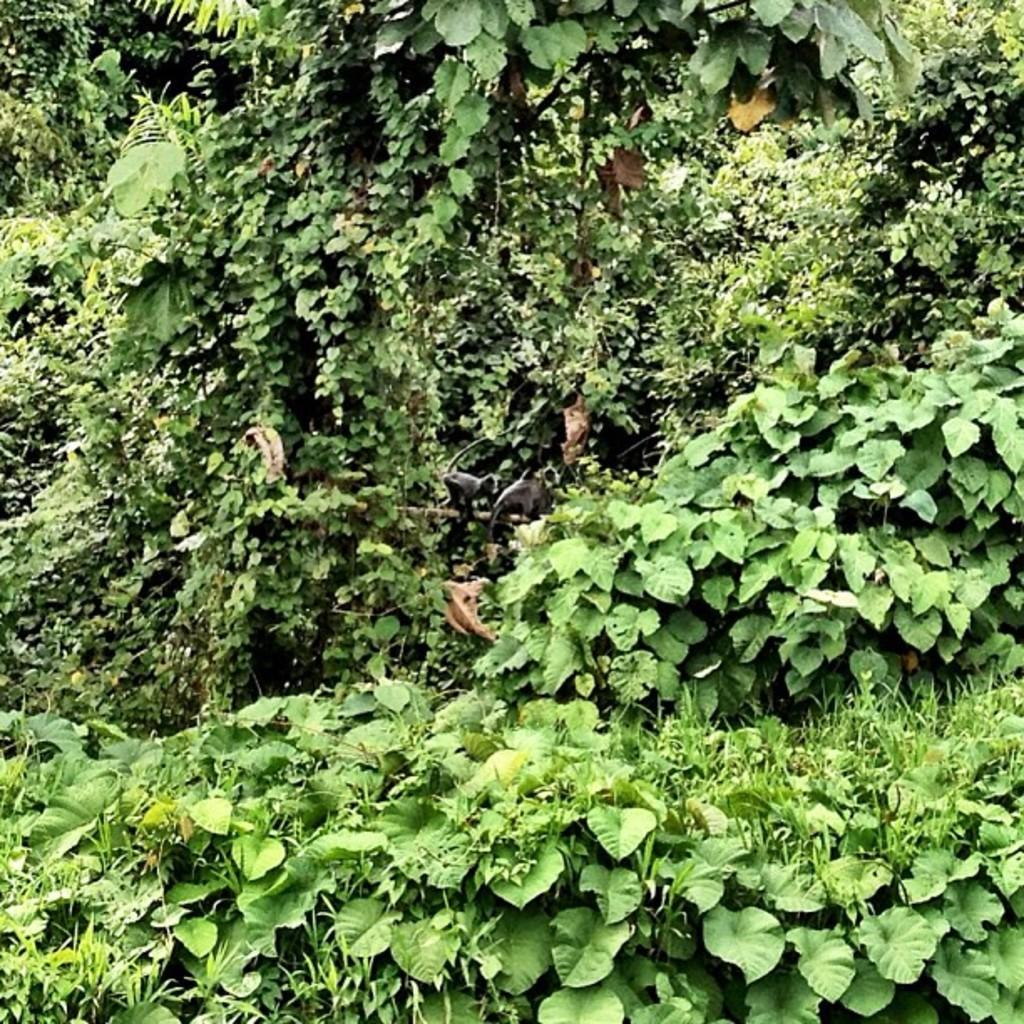What type of vegetation can be seen in the image? There are plants and trees in the image. Can you describe the plants and trees in the image? The image shows plants and trees, but specific details about their appearance cannot be determined from the provided facts. Are there any roses visible in the image? There is no mention of roses in the provided facts, so it cannot be determined if any are present in the image. Can you see any fairies interacting with the plants and trees in the image? There is no mention of fairies in the provided facts, so it cannot be determined if any are present in the image. 